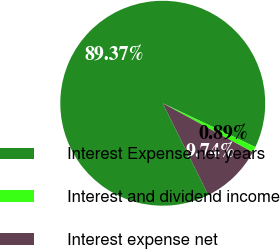<chart> <loc_0><loc_0><loc_500><loc_500><pie_chart><fcel>Interest Expense net years<fcel>Interest and dividend income<fcel>Interest expense net<nl><fcel>89.37%<fcel>0.89%<fcel>9.74%<nl></chart> 